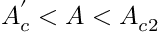<formula> <loc_0><loc_0><loc_500><loc_500>A _ { c } ^ { ^ { \prime } } < A < A _ { c 2 }</formula> 